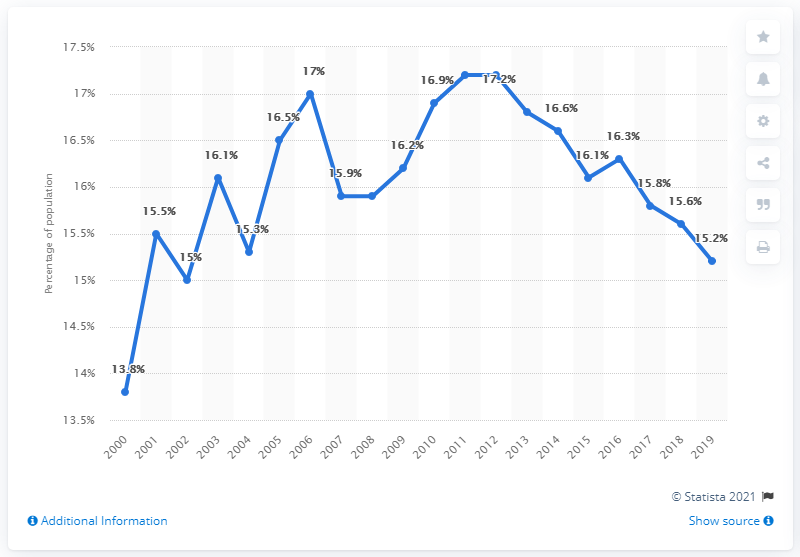List a handful of essential elements in this visual. In 2001, we can observe the most significant increase in the blue line. The sum of the two largest incremental increases across all years is 2.9. 